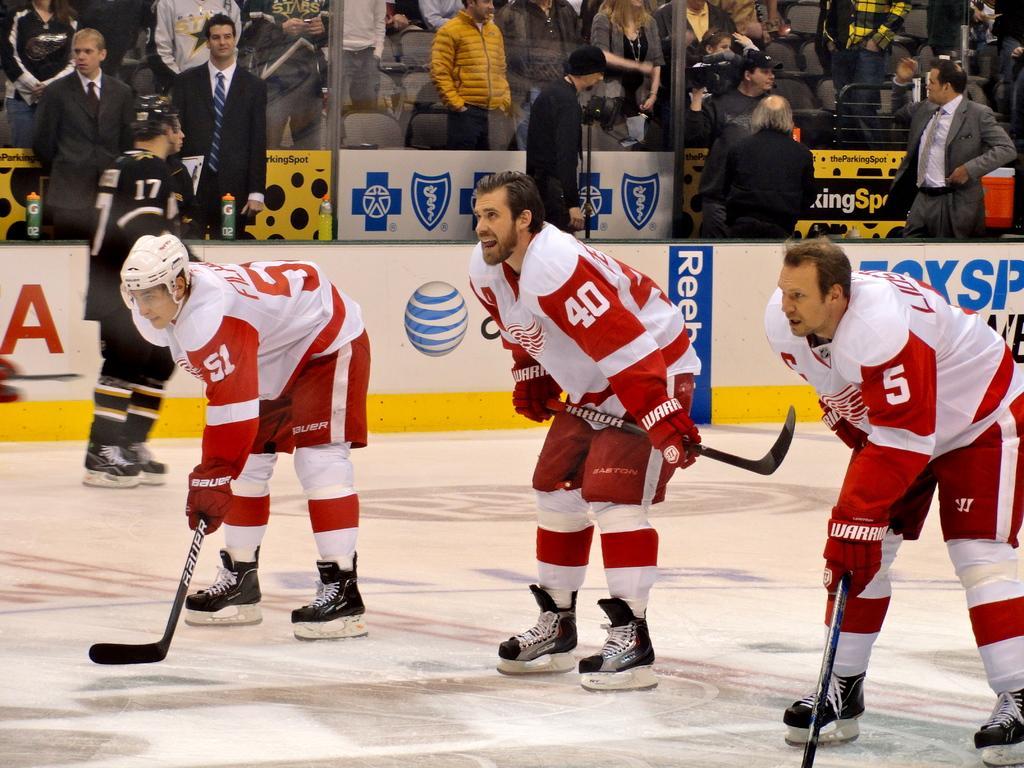Please provide a concise description of this image. In this picture we can see three players wearing white and red color dress and playing the ice hockey. Behind there is a audience watching to them. 